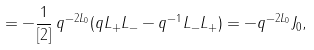<formula> <loc_0><loc_0><loc_500><loc_500>= - \frac { 1 } { [ 2 ] } \, q ^ { - 2 L _ { 0 } } ( q L _ { + } L _ { - } - q ^ { - 1 } L _ { - } L _ { + } ) = - q ^ { - 2 L _ { 0 } } J _ { 0 } ,</formula> 